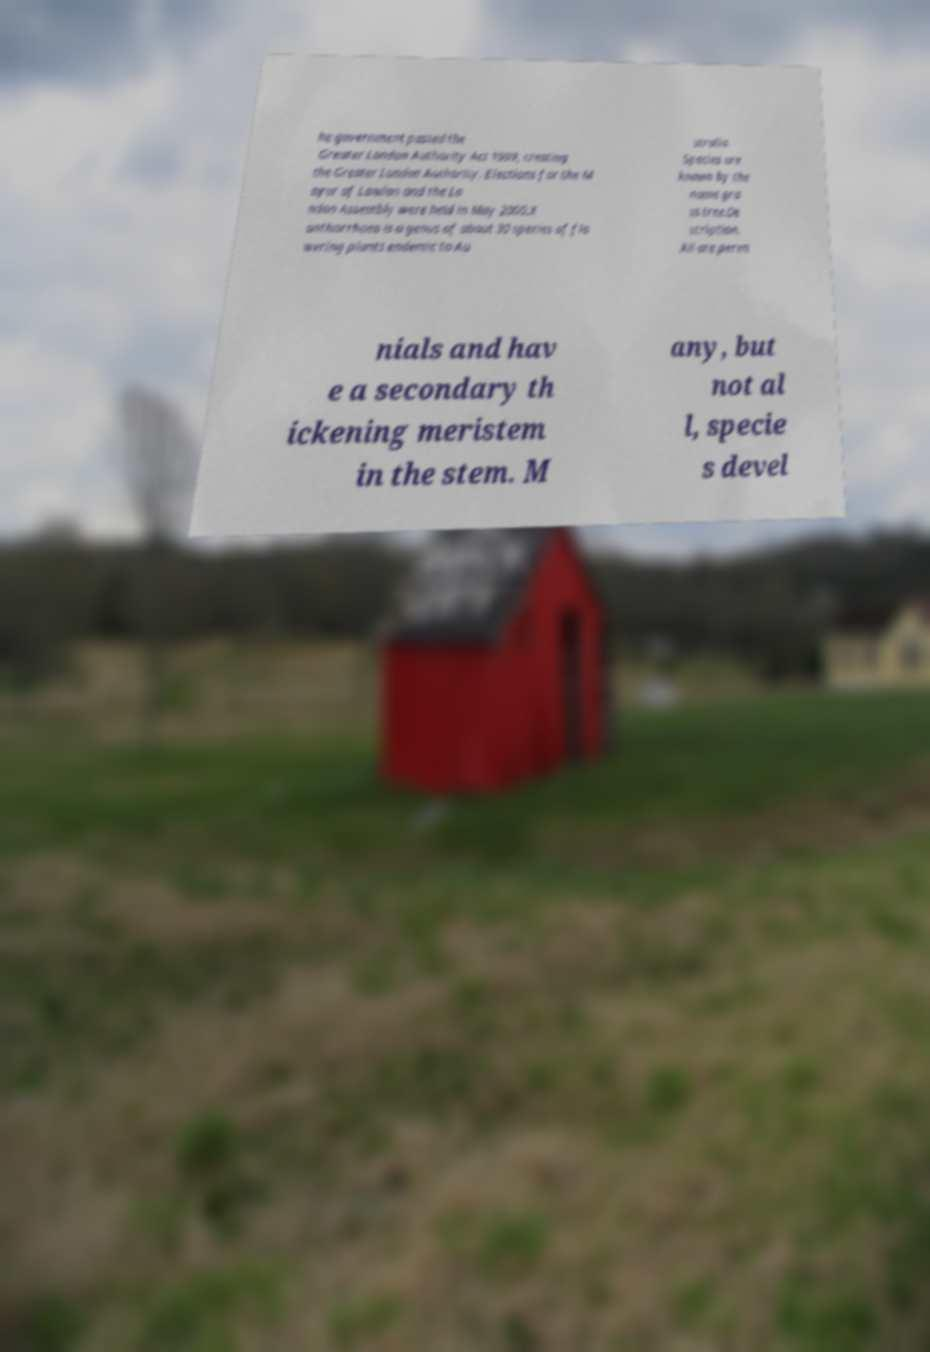Can you accurately transcribe the text from the provided image for me? he government passed the Greater London Authority Act 1999, creating the Greater London Authority. Elections for the M ayor of London and the Lo ndon Assembly were held in May 2000.X anthorrhoea is a genus of about 30 species of flo wering plants endemic to Au stralia. Species are known by the name gra ss tree.De scription. All are peren nials and hav e a secondary th ickening meristem in the stem. M any, but not al l, specie s devel 